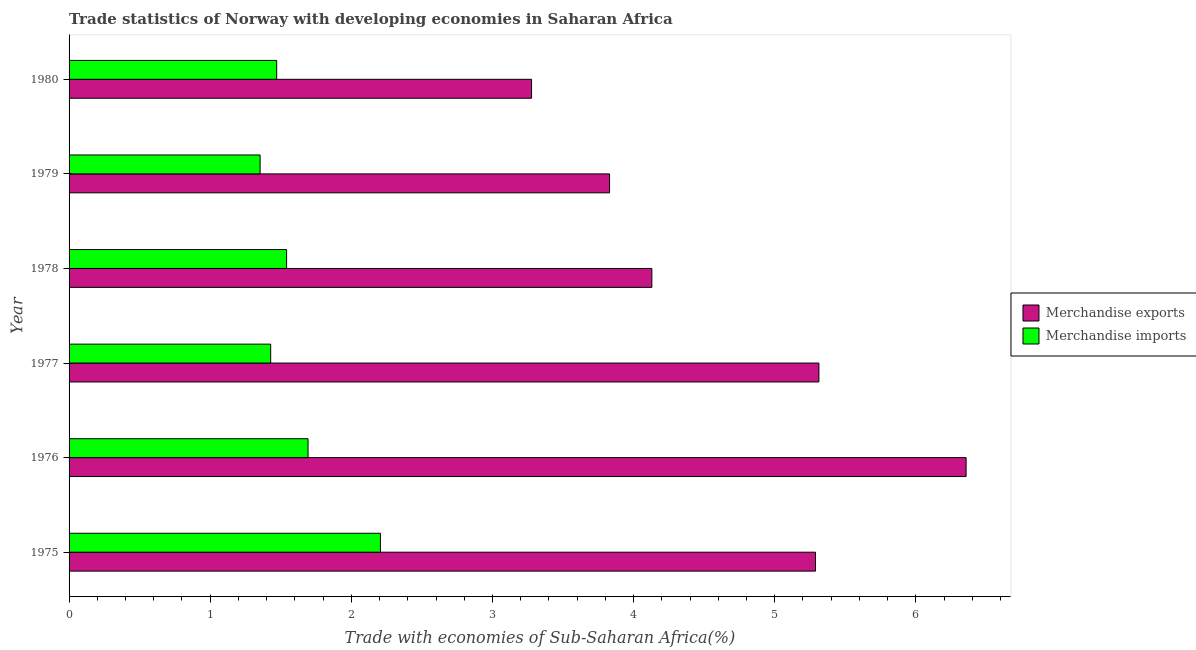How many bars are there on the 4th tick from the bottom?
Your answer should be very brief. 2. What is the label of the 2nd group of bars from the top?
Make the answer very short. 1979. In how many cases, is the number of bars for a given year not equal to the number of legend labels?
Your answer should be very brief. 0. What is the merchandise imports in 1976?
Offer a terse response. 1.69. Across all years, what is the maximum merchandise exports?
Provide a succinct answer. 6.36. Across all years, what is the minimum merchandise exports?
Your answer should be compact. 3.28. In which year was the merchandise imports maximum?
Ensure brevity in your answer.  1975. What is the total merchandise exports in the graph?
Give a very brief answer. 28.19. What is the difference between the merchandise exports in 1975 and that in 1978?
Ensure brevity in your answer.  1.16. What is the difference between the merchandise imports in 1975 and the merchandise exports in 1977?
Keep it short and to the point. -3.11. What is the average merchandise exports per year?
Keep it short and to the point. 4.7. In the year 1979, what is the difference between the merchandise exports and merchandise imports?
Keep it short and to the point. 2.48. In how many years, is the merchandise imports greater than 1.2 %?
Your response must be concise. 6. What is the ratio of the merchandise exports in 1977 to that in 1980?
Make the answer very short. 1.62. Is the merchandise exports in 1977 less than that in 1980?
Ensure brevity in your answer.  No. What is the difference between the highest and the second highest merchandise imports?
Offer a terse response. 0.51. Is the sum of the merchandise exports in 1979 and 1980 greater than the maximum merchandise imports across all years?
Provide a short and direct response. Yes. How many years are there in the graph?
Ensure brevity in your answer.  6. What is the difference between two consecutive major ticks on the X-axis?
Give a very brief answer. 1. Are the values on the major ticks of X-axis written in scientific E-notation?
Ensure brevity in your answer.  No. Does the graph contain any zero values?
Your response must be concise. No. Does the graph contain grids?
Offer a very short reply. No. Where does the legend appear in the graph?
Keep it short and to the point. Center right. How many legend labels are there?
Your answer should be compact. 2. What is the title of the graph?
Offer a very short reply. Trade statistics of Norway with developing economies in Saharan Africa. What is the label or title of the X-axis?
Keep it short and to the point. Trade with economies of Sub-Saharan Africa(%). What is the Trade with economies of Sub-Saharan Africa(%) in Merchandise exports in 1975?
Offer a very short reply. 5.29. What is the Trade with economies of Sub-Saharan Africa(%) in Merchandise imports in 1975?
Your answer should be compact. 2.21. What is the Trade with economies of Sub-Saharan Africa(%) of Merchandise exports in 1976?
Your answer should be very brief. 6.36. What is the Trade with economies of Sub-Saharan Africa(%) of Merchandise imports in 1976?
Your response must be concise. 1.69. What is the Trade with economies of Sub-Saharan Africa(%) of Merchandise exports in 1977?
Provide a succinct answer. 5.31. What is the Trade with economies of Sub-Saharan Africa(%) of Merchandise imports in 1977?
Your response must be concise. 1.43. What is the Trade with economies of Sub-Saharan Africa(%) of Merchandise exports in 1978?
Offer a terse response. 4.13. What is the Trade with economies of Sub-Saharan Africa(%) of Merchandise imports in 1978?
Offer a terse response. 1.54. What is the Trade with economies of Sub-Saharan Africa(%) in Merchandise exports in 1979?
Give a very brief answer. 3.83. What is the Trade with economies of Sub-Saharan Africa(%) in Merchandise imports in 1979?
Your answer should be compact. 1.35. What is the Trade with economies of Sub-Saharan Africa(%) in Merchandise exports in 1980?
Your answer should be compact. 3.28. What is the Trade with economies of Sub-Saharan Africa(%) of Merchandise imports in 1980?
Keep it short and to the point. 1.47. Across all years, what is the maximum Trade with economies of Sub-Saharan Africa(%) in Merchandise exports?
Your response must be concise. 6.36. Across all years, what is the maximum Trade with economies of Sub-Saharan Africa(%) in Merchandise imports?
Provide a short and direct response. 2.21. Across all years, what is the minimum Trade with economies of Sub-Saharan Africa(%) in Merchandise exports?
Your response must be concise. 3.28. Across all years, what is the minimum Trade with economies of Sub-Saharan Africa(%) in Merchandise imports?
Your answer should be compact. 1.35. What is the total Trade with economies of Sub-Saharan Africa(%) in Merchandise exports in the graph?
Your answer should be compact. 28.19. What is the total Trade with economies of Sub-Saharan Africa(%) in Merchandise imports in the graph?
Keep it short and to the point. 9.69. What is the difference between the Trade with economies of Sub-Saharan Africa(%) of Merchandise exports in 1975 and that in 1976?
Ensure brevity in your answer.  -1.07. What is the difference between the Trade with economies of Sub-Saharan Africa(%) in Merchandise imports in 1975 and that in 1976?
Your answer should be compact. 0.51. What is the difference between the Trade with economies of Sub-Saharan Africa(%) in Merchandise exports in 1975 and that in 1977?
Provide a succinct answer. -0.02. What is the difference between the Trade with economies of Sub-Saharan Africa(%) in Merchandise imports in 1975 and that in 1977?
Your answer should be very brief. 0.78. What is the difference between the Trade with economies of Sub-Saharan Africa(%) in Merchandise exports in 1975 and that in 1978?
Give a very brief answer. 1.16. What is the difference between the Trade with economies of Sub-Saharan Africa(%) in Merchandise imports in 1975 and that in 1978?
Your answer should be very brief. 0.67. What is the difference between the Trade with economies of Sub-Saharan Africa(%) in Merchandise exports in 1975 and that in 1979?
Provide a short and direct response. 1.46. What is the difference between the Trade with economies of Sub-Saharan Africa(%) of Merchandise imports in 1975 and that in 1979?
Offer a terse response. 0.85. What is the difference between the Trade with economies of Sub-Saharan Africa(%) in Merchandise exports in 1975 and that in 1980?
Give a very brief answer. 2.01. What is the difference between the Trade with economies of Sub-Saharan Africa(%) of Merchandise imports in 1975 and that in 1980?
Your response must be concise. 0.74. What is the difference between the Trade with economies of Sub-Saharan Africa(%) of Merchandise exports in 1976 and that in 1977?
Give a very brief answer. 1.04. What is the difference between the Trade with economies of Sub-Saharan Africa(%) in Merchandise imports in 1976 and that in 1977?
Give a very brief answer. 0.26. What is the difference between the Trade with economies of Sub-Saharan Africa(%) of Merchandise exports in 1976 and that in 1978?
Make the answer very short. 2.23. What is the difference between the Trade with economies of Sub-Saharan Africa(%) in Merchandise imports in 1976 and that in 1978?
Offer a very short reply. 0.15. What is the difference between the Trade with economies of Sub-Saharan Africa(%) of Merchandise exports in 1976 and that in 1979?
Offer a terse response. 2.53. What is the difference between the Trade with economies of Sub-Saharan Africa(%) in Merchandise imports in 1976 and that in 1979?
Provide a short and direct response. 0.34. What is the difference between the Trade with economies of Sub-Saharan Africa(%) of Merchandise exports in 1976 and that in 1980?
Ensure brevity in your answer.  3.08. What is the difference between the Trade with economies of Sub-Saharan Africa(%) in Merchandise imports in 1976 and that in 1980?
Your answer should be compact. 0.22. What is the difference between the Trade with economies of Sub-Saharan Africa(%) in Merchandise exports in 1977 and that in 1978?
Your answer should be very brief. 1.18. What is the difference between the Trade with economies of Sub-Saharan Africa(%) in Merchandise imports in 1977 and that in 1978?
Your answer should be compact. -0.11. What is the difference between the Trade with economies of Sub-Saharan Africa(%) of Merchandise exports in 1977 and that in 1979?
Provide a short and direct response. 1.48. What is the difference between the Trade with economies of Sub-Saharan Africa(%) of Merchandise imports in 1977 and that in 1979?
Your response must be concise. 0.07. What is the difference between the Trade with economies of Sub-Saharan Africa(%) of Merchandise exports in 1977 and that in 1980?
Keep it short and to the point. 2.04. What is the difference between the Trade with economies of Sub-Saharan Africa(%) in Merchandise imports in 1977 and that in 1980?
Ensure brevity in your answer.  -0.04. What is the difference between the Trade with economies of Sub-Saharan Africa(%) in Merchandise exports in 1978 and that in 1979?
Your answer should be very brief. 0.3. What is the difference between the Trade with economies of Sub-Saharan Africa(%) in Merchandise imports in 1978 and that in 1979?
Your answer should be compact. 0.19. What is the difference between the Trade with economies of Sub-Saharan Africa(%) of Merchandise exports in 1978 and that in 1980?
Your response must be concise. 0.85. What is the difference between the Trade with economies of Sub-Saharan Africa(%) in Merchandise imports in 1978 and that in 1980?
Give a very brief answer. 0.07. What is the difference between the Trade with economies of Sub-Saharan Africa(%) of Merchandise exports in 1979 and that in 1980?
Ensure brevity in your answer.  0.55. What is the difference between the Trade with economies of Sub-Saharan Africa(%) in Merchandise imports in 1979 and that in 1980?
Your answer should be very brief. -0.12. What is the difference between the Trade with economies of Sub-Saharan Africa(%) in Merchandise exports in 1975 and the Trade with economies of Sub-Saharan Africa(%) in Merchandise imports in 1976?
Give a very brief answer. 3.6. What is the difference between the Trade with economies of Sub-Saharan Africa(%) in Merchandise exports in 1975 and the Trade with economies of Sub-Saharan Africa(%) in Merchandise imports in 1977?
Provide a short and direct response. 3.86. What is the difference between the Trade with economies of Sub-Saharan Africa(%) of Merchandise exports in 1975 and the Trade with economies of Sub-Saharan Africa(%) of Merchandise imports in 1978?
Provide a succinct answer. 3.75. What is the difference between the Trade with economies of Sub-Saharan Africa(%) of Merchandise exports in 1975 and the Trade with economies of Sub-Saharan Africa(%) of Merchandise imports in 1979?
Keep it short and to the point. 3.94. What is the difference between the Trade with economies of Sub-Saharan Africa(%) of Merchandise exports in 1975 and the Trade with economies of Sub-Saharan Africa(%) of Merchandise imports in 1980?
Your answer should be compact. 3.82. What is the difference between the Trade with economies of Sub-Saharan Africa(%) in Merchandise exports in 1976 and the Trade with economies of Sub-Saharan Africa(%) in Merchandise imports in 1977?
Provide a short and direct response. 4.93. What is the difference between the Trade with economies of Sub-Saharan Africa(%) in Merchandise exports in 1976 and the Trade with economies of Sub-Saharan Africa(%) in Merchandise imports in 1978?
Your answer should be compact. 4.82. What is the difference between the Trade with economies of Sub-Saharan Africa(%) in Merchandise exports in 1976 and the Trade with economies of Sub-Saharan Africa(%) in Merchandise imports in 1979?
Offer a terse response. 5. What is the difference between the Trade with economies of Sub-Saharan Africa(%) in Merchandise exports in 1976 and the Trade with economies of Sub-Saharan Africa(%) in Merchandise imports in 1980?
Your answer should be compact. 4.89. What is the difference between the Trade with economies of Sub-Saharan Africa(%) in Merchandise exports in 1977 and the Trade with economies of Sub-Saharan Africa(%) in Merchandise imports in 1978?
Your answer should be compact. 3.77. What is the difference between the Trade with economies of Sub-Saharan Africa(%) of Merchandise exports in 1977 and the Trade with economies of Sub-Saharan Africa(%) of Merchandise imports in 1979?
Provide a succinct answer. 3.96. What is the difference between the Trade with economies of Sub-Saharan Africa(%) of Merchandise exports in 1977 and the Trade with economies of Sub-Saharan Africa(%) of Merchandise imports in 1980?
Your answer should be very brief. 3.84. What is the difference between the Trade with economies of Sub-Saharan Africa(%) of Merchandise exports in 1978 and the Trade with economies of Sub-Saharan Africa(%) of Merchandise imports in 1979?
Provide a succinct answer. 2.78. What is the difference between the Trade with economies of Sub-Saharan Africa(%) of Merchandise exports in 1978 and the Trade with economies of Sub-Saharan Africa(%) of Merchandise imports in 1980?
Offer a terse response. 2.66. What is the difference between the Trade with economies of Sub-Saharan Africa(%) in Merchandise exports in 1979 and the Trade with economies of Sub-Saharan Africa(%) in Merchandise imports in 1980?
Provide a short and direct response. 2.36. What is the average Trade with economies of Sub-Saharan Africa(%) of Merchandise exports per year?
Keep it short and to the point. 4.7. What is the average Trade with economies of Sub-Saharan Africa(%) in Merchandise imports per year?
Give a very brief answer. 1.62. In the year 1975, what is the difference between the Trade with economies of Sub-Saharan Africa(%) in Merchandise exports and Trade with economies of Sub-Saharan Africa(%) in Merchandise imports?
Offer a very short reply. 3.08. In the year 1976, what is the difference between the Trade with economies of Sub-Saharan Africa(%) of Merchandise exports and Trade with economies of Sub-Saharan Africa(%) of Merchandise imports?
Provide a short and direct response. 4.66. In the year 1977, what is the difference between the Trade with economies of Sub-Saharan Africa(%) in Merchandise exports and Trade with economies of Sub-Saharan Africa(%) in Merchandise imports?
Give a very brief answer. 3.88. In the year 1978, what is the difference between the Trade with economies of Sub-Saharan Africa(%) in Merchandise exports and Trade with economies of Sub-Saharan Africa(%) in Merchandise imports?
Give a very brief answer. 2.59. In the year 1979, what is the difference between the Trade with economies of Sub-Saharan Africa(%) of Merchandise exports and Trade with economies of Sub-Saharan Africa(%) of Merchandise imports?
Offer a terse response. 2.48. In the year 1980, what is the difference between the Trade with economies of Sub-Saharan Africa(%) of Merchandise exports and Trade with economies of Sub-Saharan Africa(%) of Merchandise imports?
Your answer should be very brief. 1.81. What is the ratio of the Trade with economies of Sub-Saharan Africa(%) in Merchandise exports in 1975 to that in 1976?
Give a very brief answer. 0.83. What is the ratio of the Trade with economies of Sub-Saharan Africa(%) of Merchandise imports in 1975 to that in 1976?
Your answer should be very brief. 1.3. What is the ratio of the Trade with economies of Sub-Saharan Africa(%) in Merchandise exports in 1975 to that in 1977?
Your response must be concise. 1. What is the ratio of the Trade with economies of Sub-Saharan Africa(%) of Merchandise imports in 1975 to that in 1977?
Your answer should be very brief. 1.54. What is the ratio of the Trade with economies of Sub-Saharan Africa(%) in Merchandise exports in 1975 to that in 1978?
Keep it short and to the point. 1.28. What is the ratio of the Trade with economies of Sub-Saharan Africa(%) in Merchandise imports in 1975 to that in 1978?
Provide a short and direct response. 1.43. What is the ratio of the Trade with economies of Sub-Saharan Africa(%) of Merchandise exports in 1975 to that in 1979?
Your response must be concise. 1.38. What is the ratio of the Trade with economies of Sub-Saharan Africa(%) of Merchandise imports in 1975 to that in 1979?
Your answer should be compact. 1.63. What is the ratio of the Trade with economies of Sub-Saharan Africa(%) of Merchandise exports in 1975 to that in 1980?
Your answer should be very brief. 1.61. What is the ratio of the Trade with economies of Sub-Saharan Africa(%) of Merchandise imports in 1975 to that in 1980?
Give a very brief answer. 1.5. What is the ratio of the Trade with economies of Sub-Saharan Africa(%) in Merchandise exports in 1976 to that in 1977?
Provide a short and direct response. 1.2. What is the ratio of the Trade with economies of Sub-Saharan Africa(%) in Merchandise imports in 1976 to that in 1977?
Offer a terse response. 1.19. What is the ratio of the Trade with economies of Sub-Saharan Africa(%) of Merchandise exports in 1976 to that in 1978?
Keep it short and to the point. 1.54. What is the ratio of the Trade with economies of Sub-Saharan Africa(%) of Merchandise imports in 1976 to that in 1978?
Give a very brief answer. 1.1. What is the ratio of the Trade with economies of Sub-Saharan Africa(%) of Merchandise exports in 1976 to that in 1979?
Your answer should be very brief. 1.66. What is the ratio of the Trade with economies of Sub-Saharan Africa(%) of Merchandise imports in 1976 to that in 1979?
Offer a terse response. 1.25. What is the ratio of the Trade with economies of Sub-Saharan Africa(%) in Merchandise exports in 1976 to that in 1980?
Offer a terse response. 1.94. What is the ratio of the Trade with economies of Sub-Saharan Africa(%) of Merchandise imports in 1976 to that in 1980?
Give a very brief answer. 1.15. What is the ratio of the Trade with economies of Sub-Saharan Africa(%) of Merchandise exports in 1977 to that in 1978?
Your answer should be very brief. 1.29. What is the ratio of the Trade with economies of Sub-Saharan Africa(%) in Merchandise imports in 1977 to that in 1978?
Your response must be concise. 0.93. What is the ratio of the Trade with economies of Sub-Saharan Africa(%) in Merchandise exports in 1977 to that in 1979?
Keep it short and to the point. 1.39. What is the ratio of the Trade with economies of Sub-Saharan Africa(%) in Merchandise imports in 1977 to that in 1979?
Make the answer very short. 1.06. What is the ratio of the Trade with economies of Sub-Saharan Africa(%) of Merchandise exports in 1977 to that in 1980?
Offer a terse response. 1.62. What is the ratio of the Trade with economies of Sub-Saharan Africa(%) of Merchandise exports in 1978 to that in 1979?
Provide a succinct answer. 1.08. What is the ratio of the Trade with economies of Sub-Saharan Africa(%) in Merchandise imports in 1978 to that in 1979?
Ensure brevity in your answer.  1.14. What is the ratio of the Trade with economies of Sub-Saharan Africa(%) in Merchandise exports in 1978 to that in 1980?
Offer a very short reply. 1.26. What is the ratio of the Trade with economies of Sub-Saharan Africa(%) of Merchandise imports in 1978 to that in 1980?
Ensure brevity in your answer.  1.05. What is the ratio of the Trade with economies of Sub-Saharan Africa(%) in Merchandise exports in 1979 to that in 1980?
Give a very brief answer. 1.17. What is the ratio of the Trade with economies of Sub-Saharan Africa(%) of Merchandise imports in 1979 to that in 1980?
Your answer should be compact. 0.92. What is the difference between the highest and the second highest Trade with economies of Sub-Saharan Africa(%) in Merchandise exports?
Your answer should be compact. 1.04. What is the difference between the highest and the second highest Trade with economies of Sub-Saharan Africa(%) of Merchandise imports?
Give a very brief answer. 0.51. What is the difference between the highest and the lowest Trade with economies of Sub-Saharan Africa(%) in Merchandise exports?
Provide a succinct answer. 3.08. What is the difference between the highest and the lowest Trade with economies of Sub-Saharan Africa(%) in Merchandise imports?
Your answer should be very brief. 0.85. 